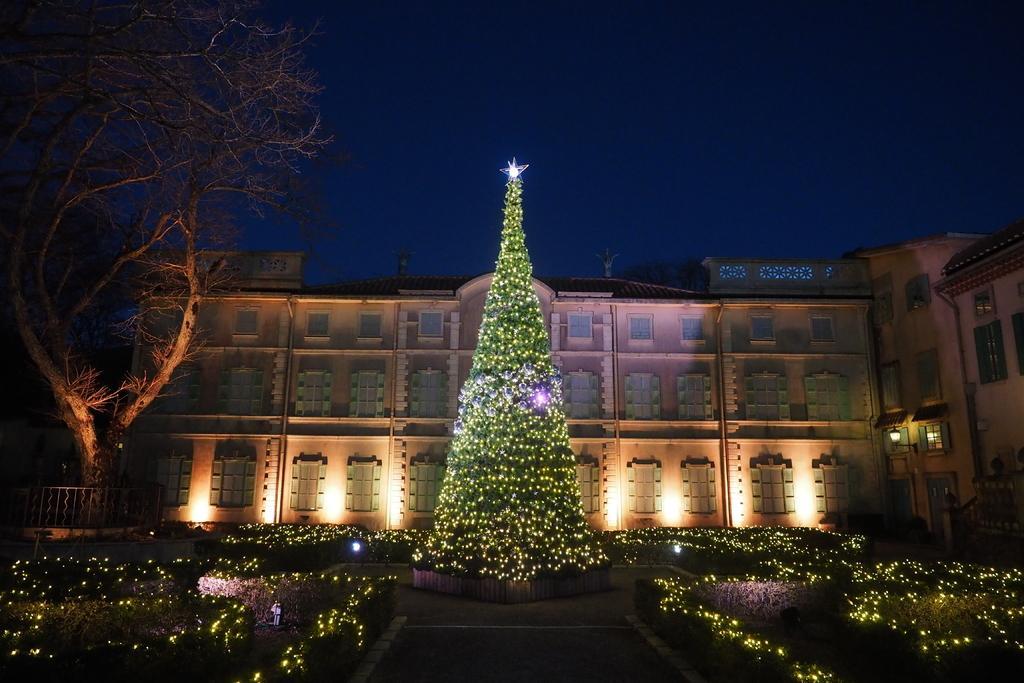Can you describe this image briefly? In the center of the image there is a Christmas tree with lights. There are plants with lights at the bottom of the image. In the background of the image there is a building. To the left side of the image there is a tree. At the top of the image there is sky. 